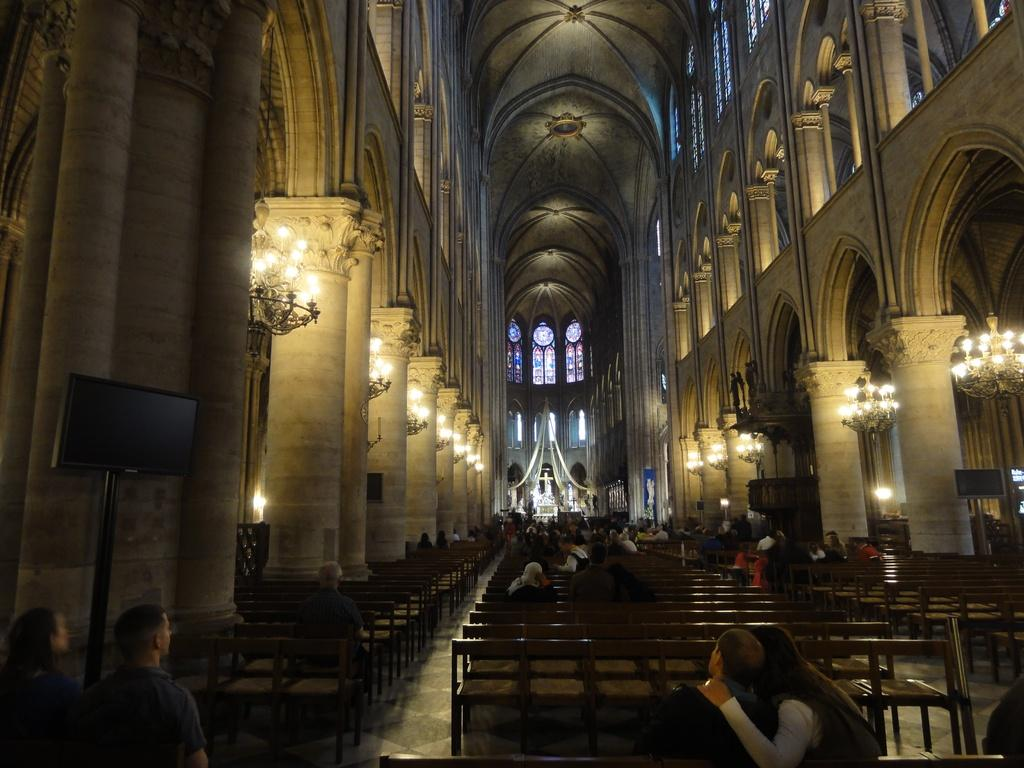What type of building is depicted in the image? The image shows a church. What are the people in the church doing? Some people are seated, while others are standing. What devices are present in the church? There are screens in the church. What can be seen providing illumination in the church? There are lights in the church. Can you hear the sound of the tub in the image? There is no tub present in the image, so it is not possible to hear any sound from it. 